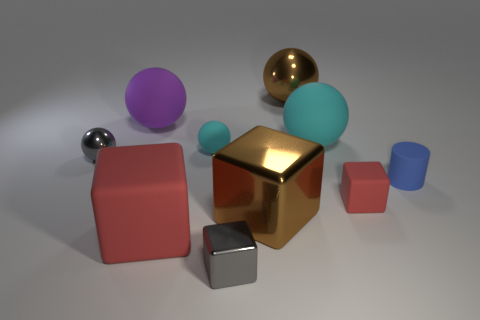There is another rubber block that is the same color as the small rubber cube; what size is it?
Keep it short and to the point. Large. Are there any other things that have the same color as the small cylinder?
Provide a succinct answer. No. There is a gray object on the right side of the red rubber thing left of the large cyan ball; are there any rubber spheres that are on the right side of it?
Offer a very short reply. Yes. Do the large rubber ball in front of the big purple ball and the small matte thing that is behind the cylinder have the same color?
Offer a very short reply. Yes. There is a cyan thing that is the same size as the blue thing; what material is it?
Make the answer very short. Rubber. How big is the brown shiny thing that is behind the cylinder to the right of the gray thing that is in front of the blue object?
Provide a short and direct response. Large. How many other things are there of the same material as the gray block?
Give a very brief answer. 3. There is a red cube that is to the right of the large shiny block; how big is it?
Make the answer very short. Small. How many tiny rubber objects are both behind the gray ball and on the right side of the large cyan ball?
Your response must be concise. 0. What is the material of the red block that is left of the metallic object that is behind the big purple object?
Your answer should be very brief. Rubber. 